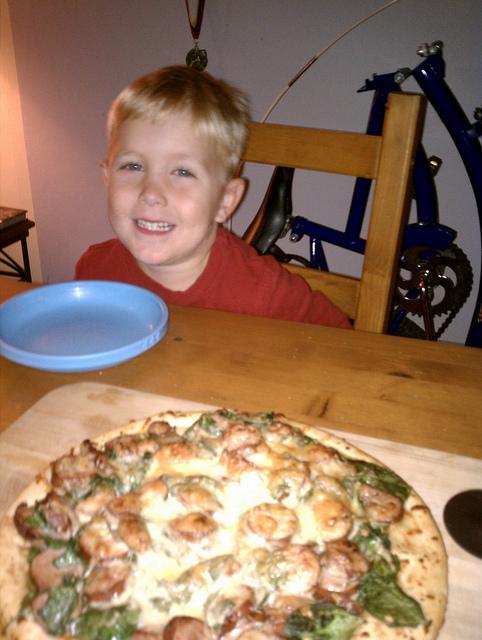How many slices does this pizza have?
Keep it brief. 0. Is the pizza large enough to feed more than just the boy?
Short answer required. Yes. Does this child have siblings?
Short answer required. No. What color is his shirt?
Keep it brief. Red. 